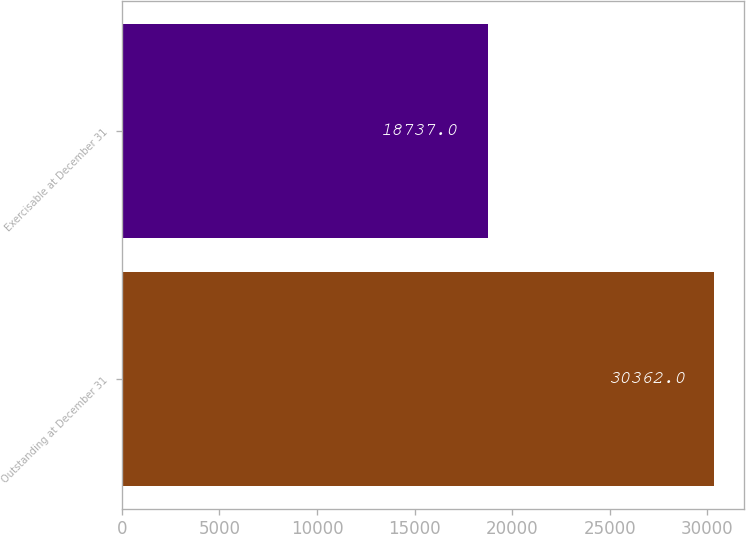Convert chart. <chart><loc_0><loc_0><loc_500><loc_500><bar_chart><fcel>Outstanding at December 31<fcel>Exercisable at December 31<nl><fcel>30362<fcel>18737<nl></chart> 